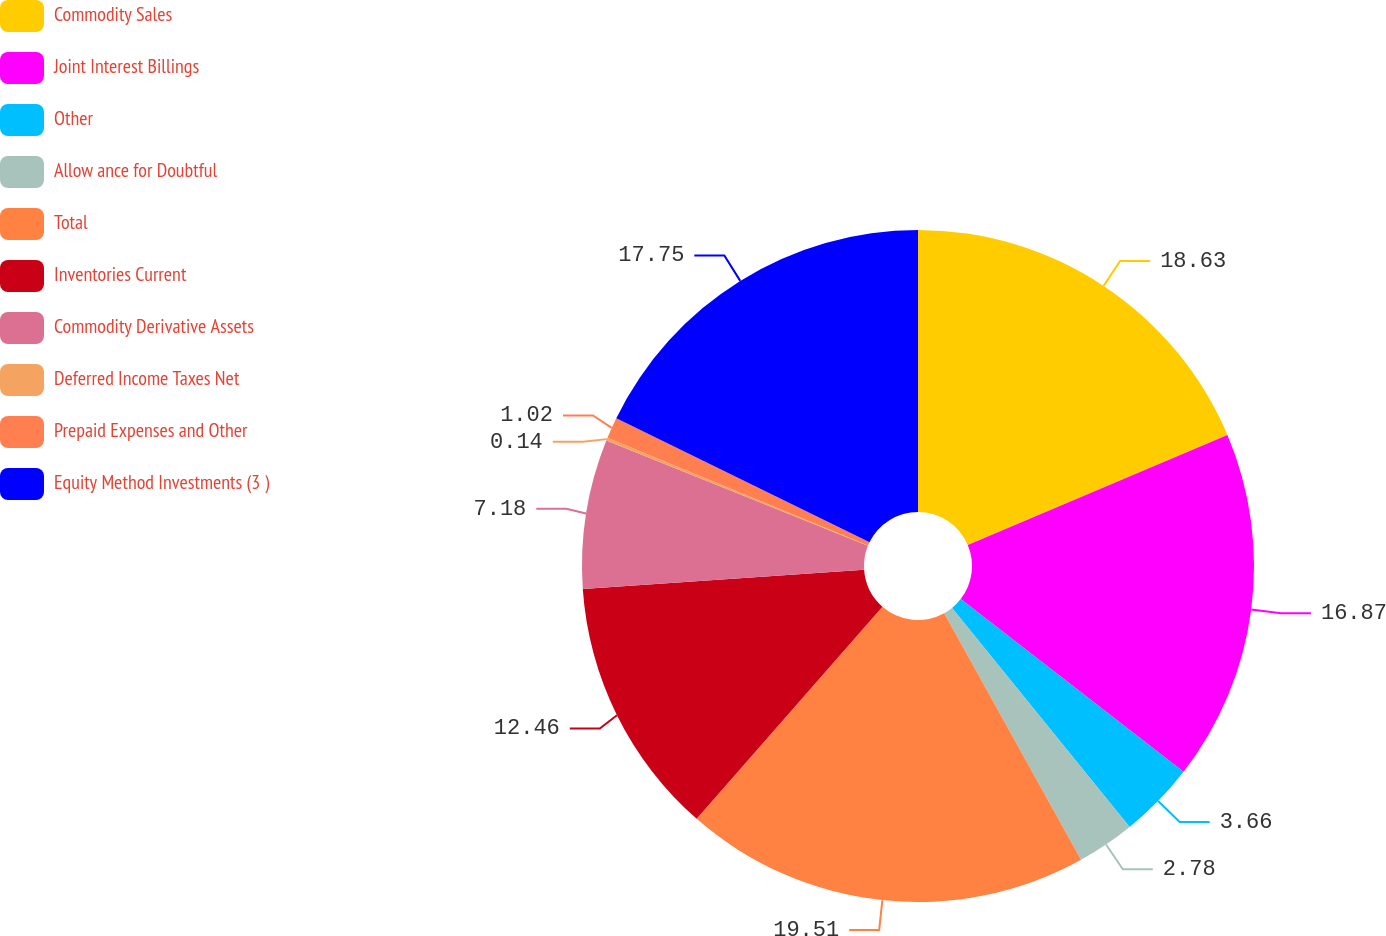<chart> <loc_0><loc_0><loc_500><loc_500><pie_chart><fcel>Commodity Sales<fcel>Joint Interest Billings<fcel>Other<fcel>Allow ance for Doubtful<fcel>Total<fcel>Inventories Current<fcel>Commodity Derivative Assets<fcel>Deferred Income Taxes Net<fcel>Prepaid Expenses and Other<fcel>Equity Method Investments (3 )<nl><fcel>18.62%<fcel>16.86%<fcel>3.66%<fcel>2.78%<fcel>19.5%<fcel>12.46%<fcel>7.18%<fcel>0.14%<fcel>1.02%<fcel>17.74%<nl></chart> 